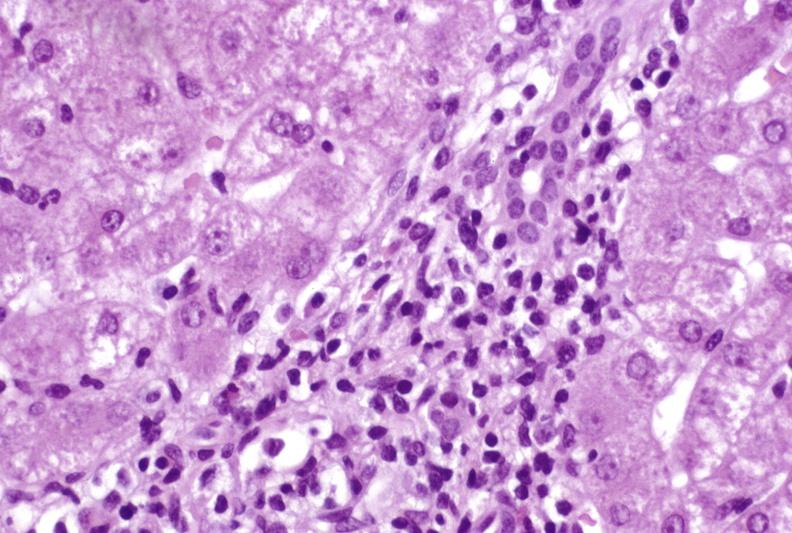does this image show moderate acute rejection?
Answer the question using a single word or phrase. Yes 